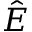Convert formula to latex. <formula><loc_0><loc_0><loc_500><loc_500>\hat { E }</formula> 